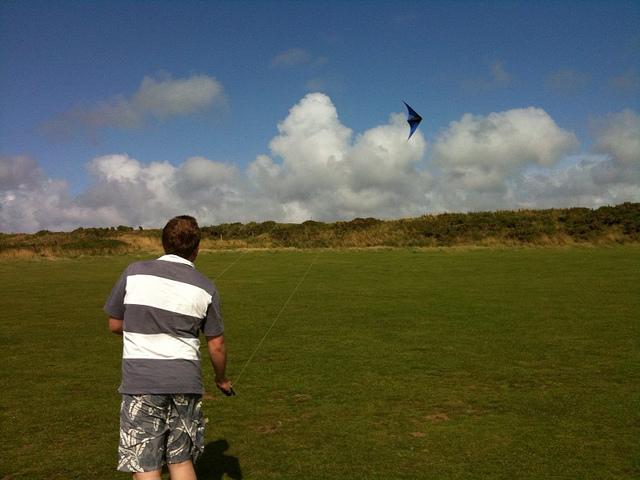Is it cold outside?
Quick response, please. No. How many hands is the man using to control the kite?
Short answer required. 2. Are there any children in the picture?
Give a very brief answer. No. What is this man dressed as?
Write a very short answer. Casual. Is this a good place to fly a kite?
Quick response, please. Yes. What is the guy flying?
Quick response, please. Kite. Is this a fair?
Answer briefly. No. 